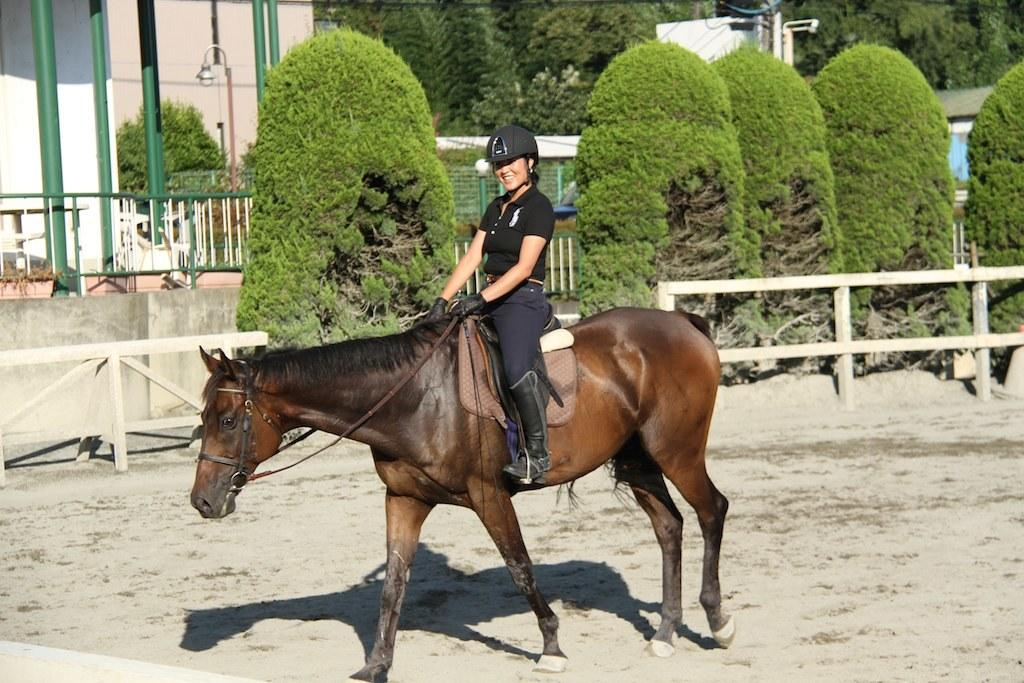Who is the main subject in the image? There is a woman in the image. What is the woman doing in the image? The woman is sitting on a horse. What can be seen in the background of the image? There are buildings, a street pole, a street light, trees, and a pole in the background of the image. How many quarters can be seen on the horse in the image? There are no quarters visible on the horse in the image. What type of pizzas are being served to the men in the image? There are no men or pizzas present in the image. 